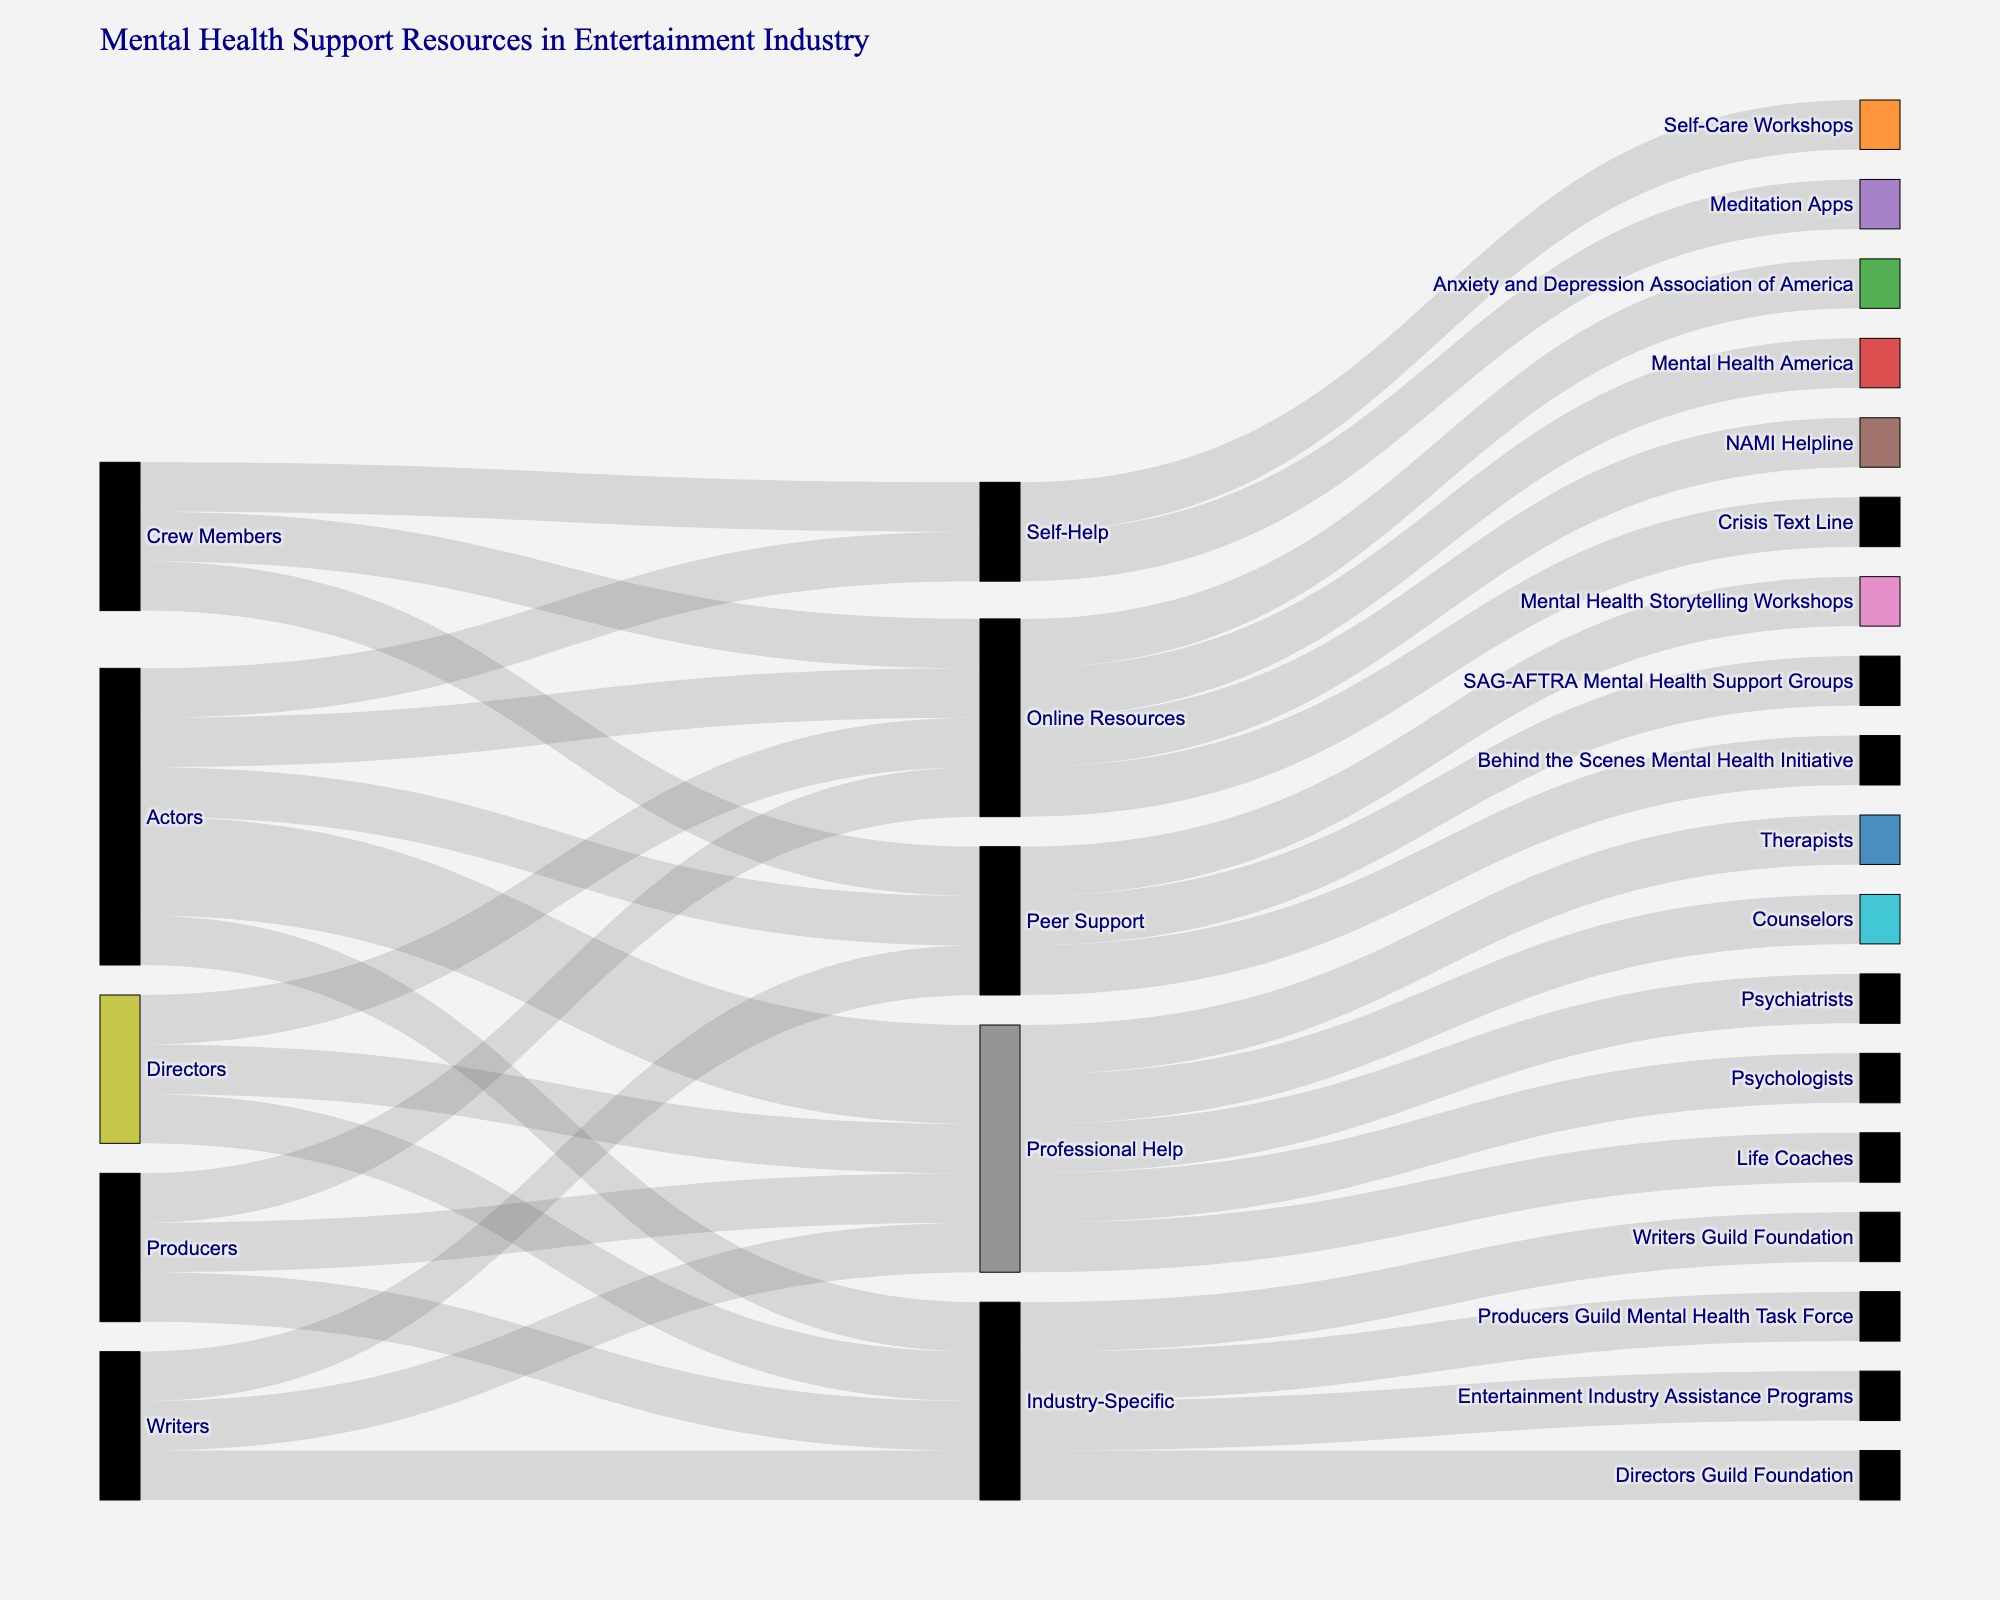How many different job roles are represented in the Sankey Diagram? Count the unique job roles listed in the 'Source' column. They are: Actors, Directors, Crew Members, Writers, and Producers.
Answer: 5 What type of resource do Actors most commonly access after online resources? Follow the path from Actors to the most common intermediate resource after Online Resources. It is Professional Help.
Answer: Professional Help Which job role accesses the Crisis Text Line? Look at the Destination nodes and trace back to the Source for Crisis Text Line. It is accessed by Crew Members.
Answer: Crew Members Do more Writers access Industry-Specific resources or Peer Support resources? Compare the paths for Writers leading to Industry-Specific (Writers Guild Foundation) and Peer Support (Mental Health Storytelling Workshops). Both have one path leading to them.
Answer: Equal How many unique destinations are there in total? Count the unique values in the 'Destination' column. They are: NAMI Helpline, Therapists, Psychiatrists, Entertainment Industry Assistance Programs, SAG-AFTRA Mental Health Support Groups, Meditation Apps, Mental Health America, Psychologists, Directors Guild Foundation, Crisis Text Line, Behind the Scenes Mental Health Initiative, Self-Care Workshops, Counselors, Writers Guild Foundation, Mental Health Storytelling Workshops, Anxiety and Depression Association of America, Life Coaches, Producers Guild Mental Health Task Force.
Answer: 18 Which job roles access resources through Peer Support? Trace all paths from 'Source' to 'Peer Support' in the 'Intermediate' column and list the corresponding job roles. They are: Actors, Crew Members, Writers.
Answer: Actors, Crew Members, Writers What is the destination for the Online Resources accessed by Producers? Follow the paths from Producers to Online Resources in the 'Intermediate' column, then to its destination. It leads to Anxiety and Depression Association of America.
Answer: Anxiety and Depression Association of America Which intermediate resource is accessed by the most diverse job roles? Identify the intermediate resources and count the unique job roles accessing each. Professional Help is accessed by Actors, Directors, Writers, and Producers, the most diverse group.
Answer: Professional Help Do more job roles access Professional Help or Industry-Specific resources? Compare the number of unique job roles connected to Professional Help (Actors, Directors, Writers, Producers) and Industry-Specific resources (Actors, Directors, Writers, Producers). Both are accessed by the same number of job roles.
Answer: Equal Are there any job roles that only access one type of resource? Check if any source has paths leading to only one intermediate resource. None, as each job role accesses multiple types of resources.
Answer: No 